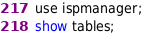Convert code to text. <code><loc_0><loc_0><loc_500><loc_500><_SQL_>use ispmanager;
show tables;</code> 